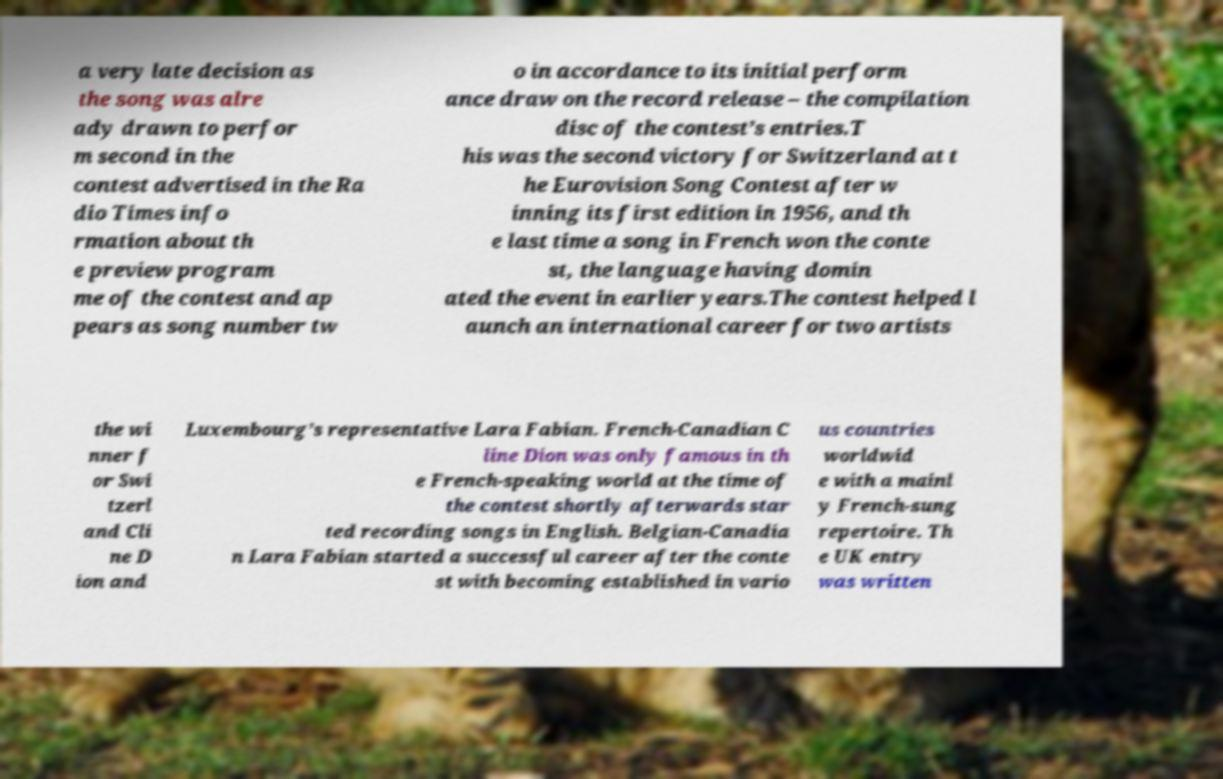Could you assist in decoding the text presented in this image and type it out clearly? a very late decision as the song was alre ady drawn to perfor m second in the contest advertised in the Ra dio Times info rmation about th e preview program me of the contest and ap pears as song number tw o in accordance to its initial perform ance draw on the record release – the compilation disc of the contest’s entries.T his was the second victory for Switzerland at t he Eurovision Song Contest after w inning its first edition in 1956, and th e last time a song in French won the conte st, the language having domin ated the event in earlier years.The contest helped l aunch an international career for two artists the wi nner f or Swi tzerl and Cli ne D ion and Luxembourg’s representative Lara Fabian. French-Canadian C line Dion was only famous in th e French-speaking world at the time of the contest shortly afterwards star ted recording songs in English. Belgian-Canadia n Lara Fabian started a successful career after the conte st with becoming established in vario us countries worldwid e with a mainl y French-sung repertoire. Th e UK entry was written 